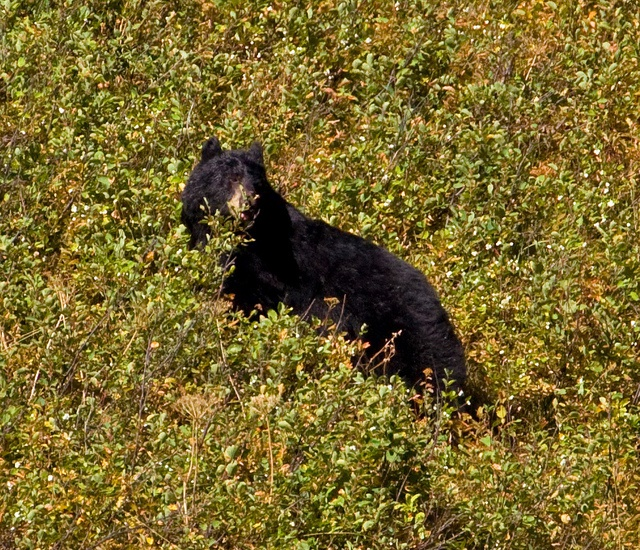Describe the objects in this image and their specific colors. I can see a bear in khaki, black, gray, and olive tones in this image. 